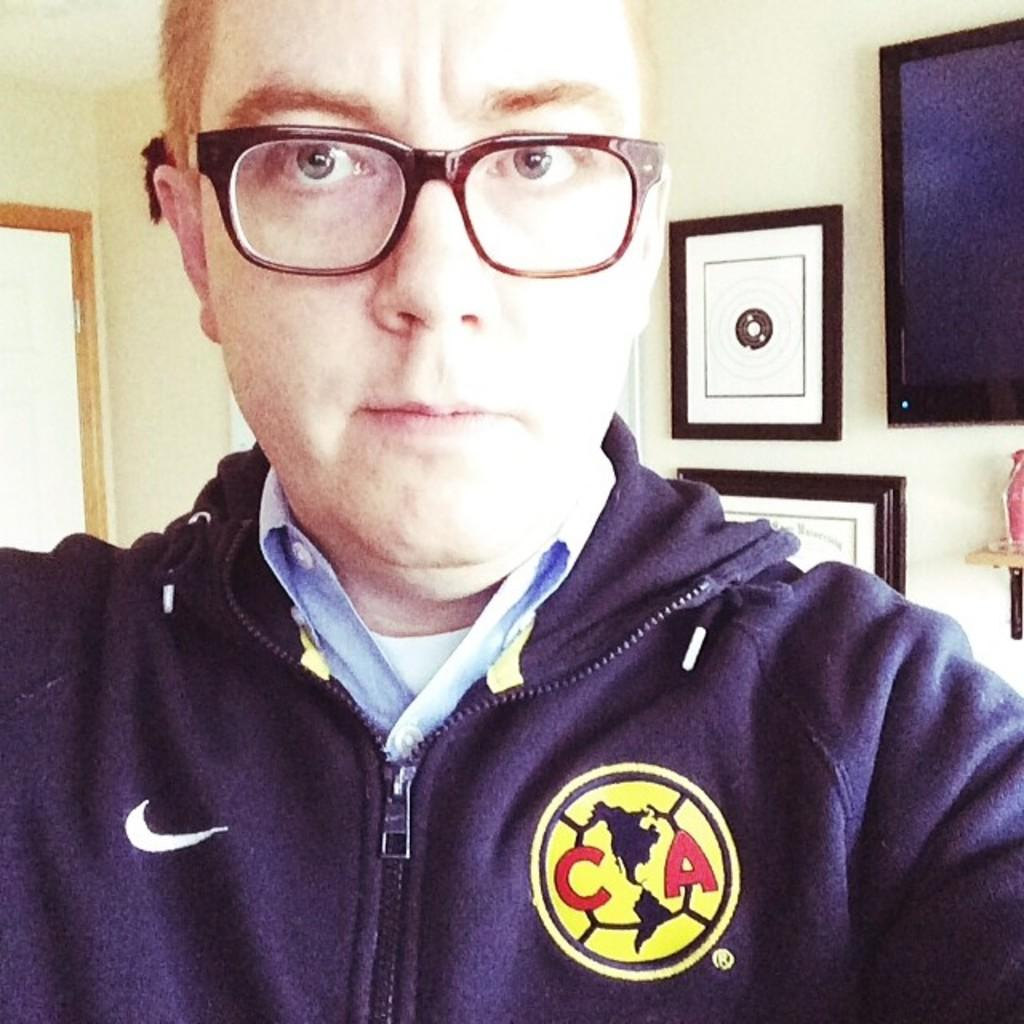Who is present in the image? There is a person in the image. What can be seen on the person's face? The person is wearing spectacles. What is a feature of the room in the image? There is a door visible in the image. What is on the wall in the image? There are objects on the wall in the image. What object resembles a television in the image? There is a black color object that looks like a television in the image. Can you see a giraffe in the image? No, there is no giraffe present in the image. What color is the space in the image? The image does not depict space, so it is not possible to determine the color of space in the image. 